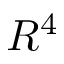<formula> <loc_0><loc_0><loc_500><loc_500>R ^ { 4 }</formula> 